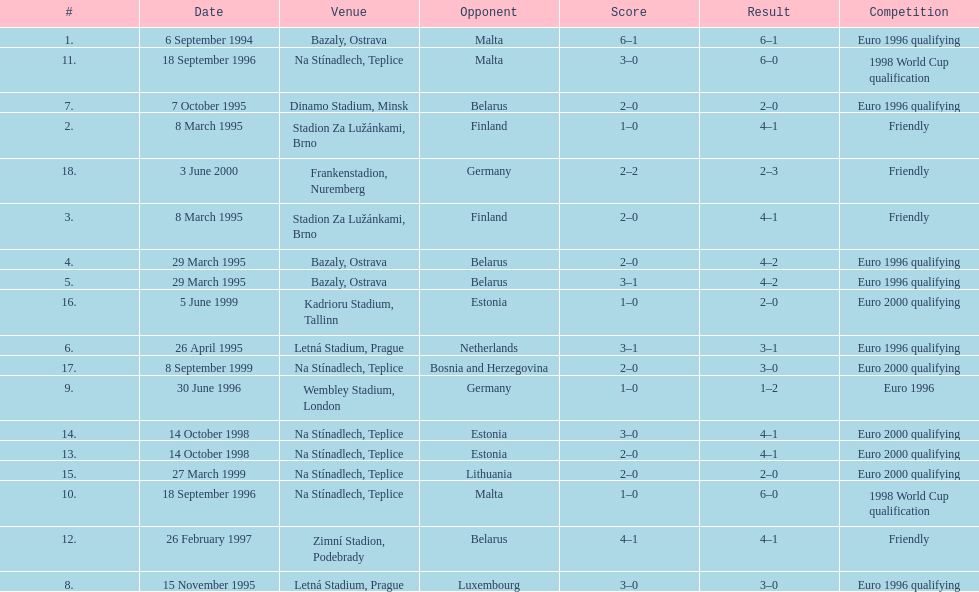What venue is listed above wembley stadium, london? Letná Stadium, Prague. 